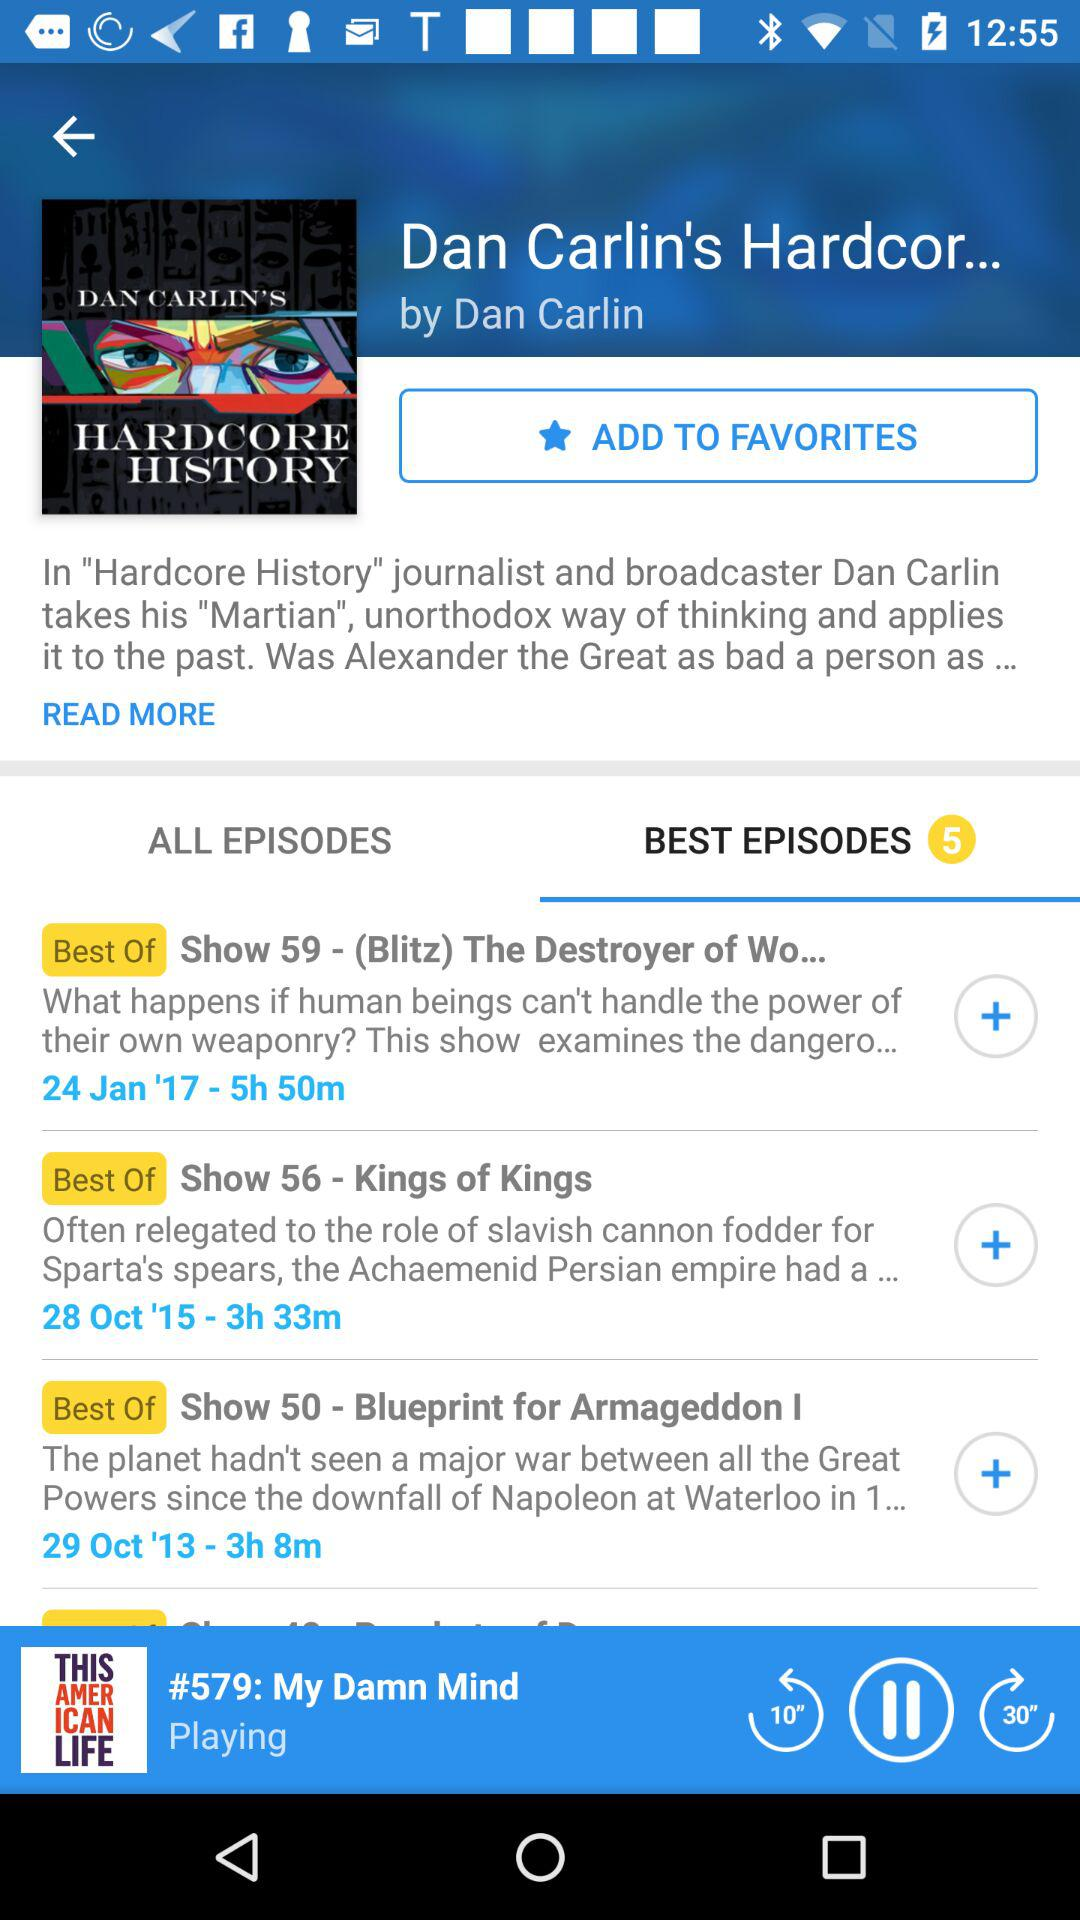How many best episodes are there? There are 5 best episodes. 